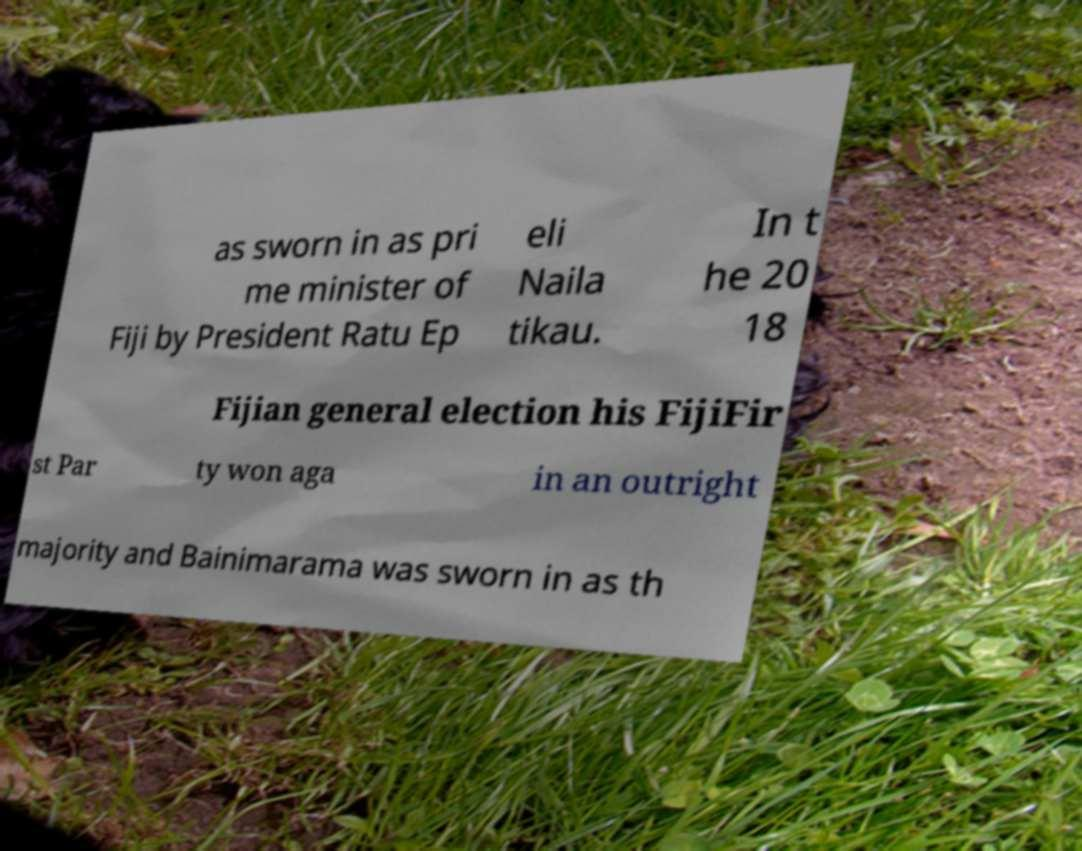What messages or text are displayed in this image? I need them in a readable, typed format. as sworn in as pri me minister of Fiji by President Ratu Ep eli Naila tikau. In t he 20 18 Fijian general election his FijiFir st Par ty won aga in an outright majority and Bainimarama was sworn in as th 